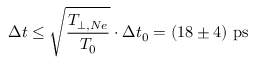Convert formula to latex. <formula><loc_0><loc_0><loc_500><loc_500>\Delta t \leq \sqrt { \frac { T _ { \perp , N e } } { T _ { 0 } } } \cdot \Delta t _ { 0 } = ( 1 8 \pm 4 ) p s</formula> 